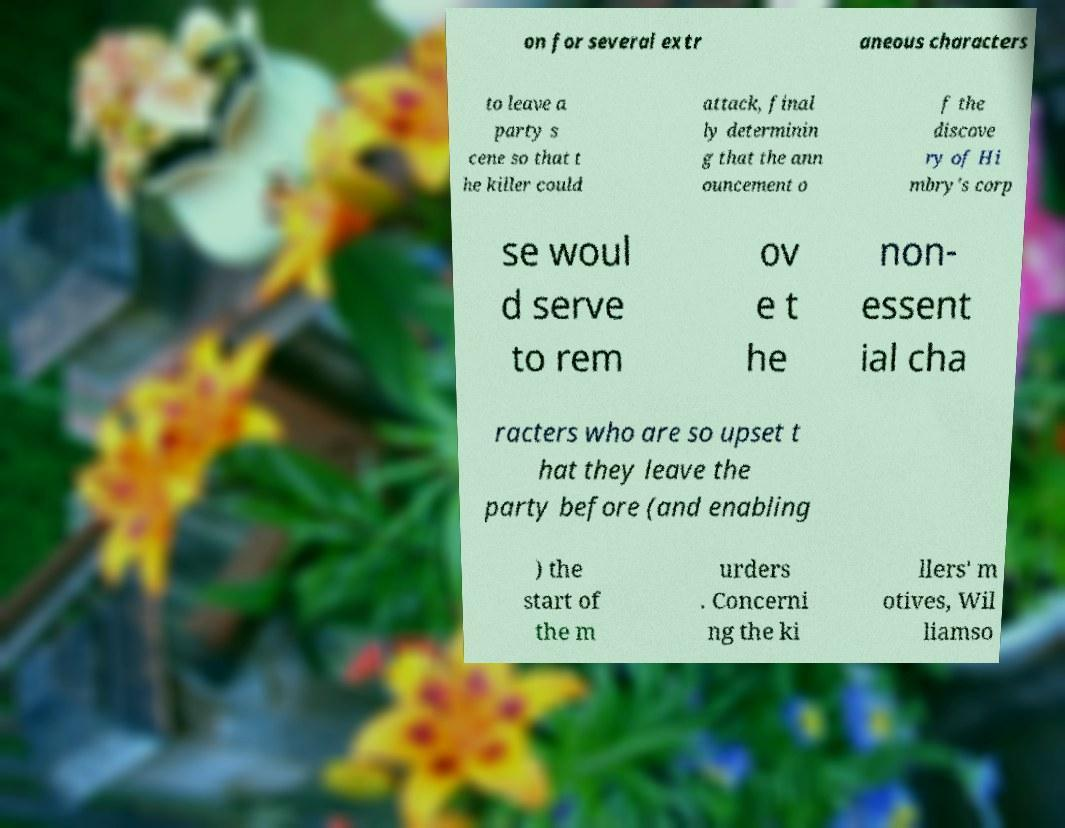There's text embedded in this image that I need extracted. Can you transcribe it verbatim? on for several extr aneous characters to leave a party s cene so that t he killer could attack, final ly determinin g that the ann ouncement o f the discove ry of Hi mbry's corp se woul d serve to rem ov e t he non- essent ial cha racters who are so upset t hat they leave the party before (and enabling ) the start of the m urders . Concerni ng the ki llers' m otives, Wil liamso 